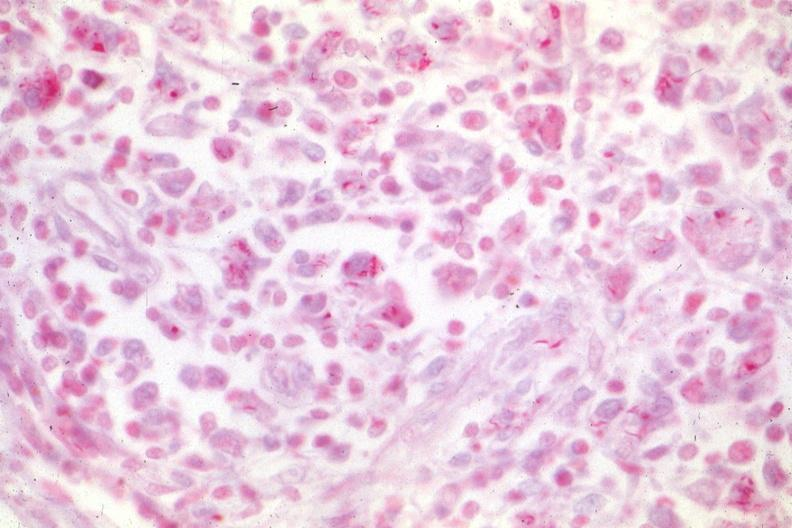does this image show typical case of hemophilia with aids?
Answer the question using a single word or phrase. Yes 